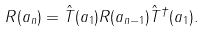Convert formula to latex. <formula><loc_0><loc_0><loc_500><loc_500>R ( a _ { n } ) = \hat { T } ( a _ { 1 } ) R ( a _ { n - 1 } ) \hat { T } ^ { \dagger } ( a _ { 1 } ) .</formula> 